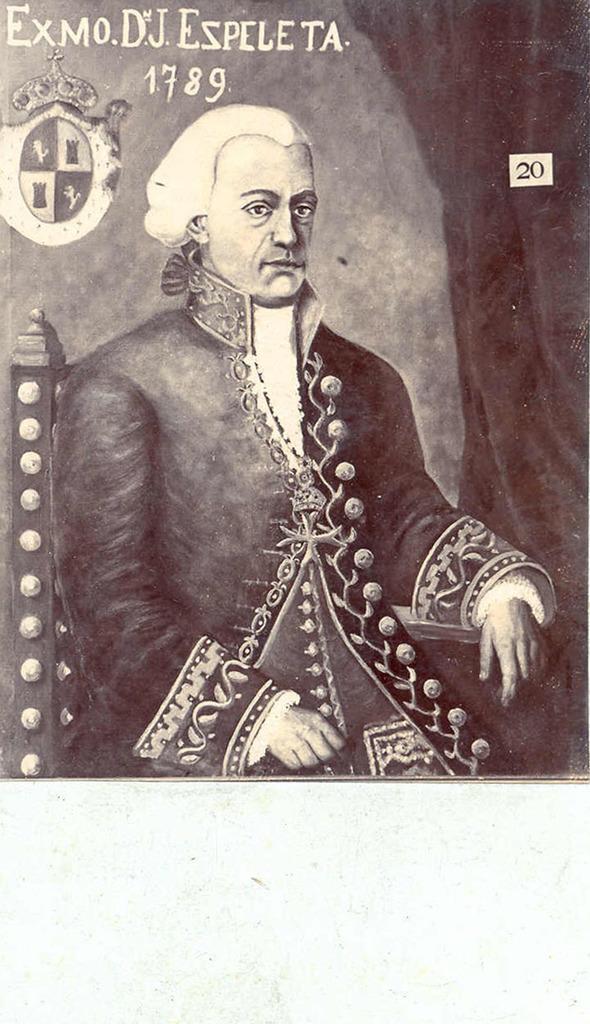Describe this image in one or two sentences. In the foreground of this poster, there is a painting of a man sitting on the chair. On the right, there is curtain and an object is on the wall. On the top, there is some text. 